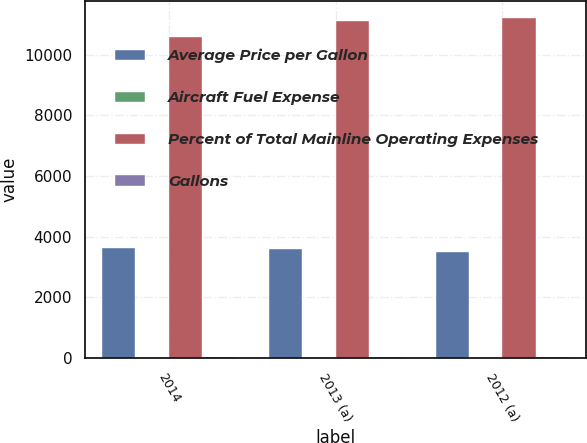<chart> <loc_0><loc_0><loc_500><loc_500><stacked_bar_chart><ecel><fcel>2014<fcel>2013 (a)<fcel>2012 (a)<nl><fcel>Average Price per Gallon<fcel>3644<fcel>3608<fcel>3512<nl><fcel>Aircraft Fuel Expense<fcel>2.91<fcel>3.08<fcel>3.19<nl><fcel>Percent of Total Mainline Operating Expenses<fcel>10592<fcel>11109<fcel>11194<nl><fcel>Gallons<fcel>33.2<fcel>35.4<fcel>35.8<nl></chart> 